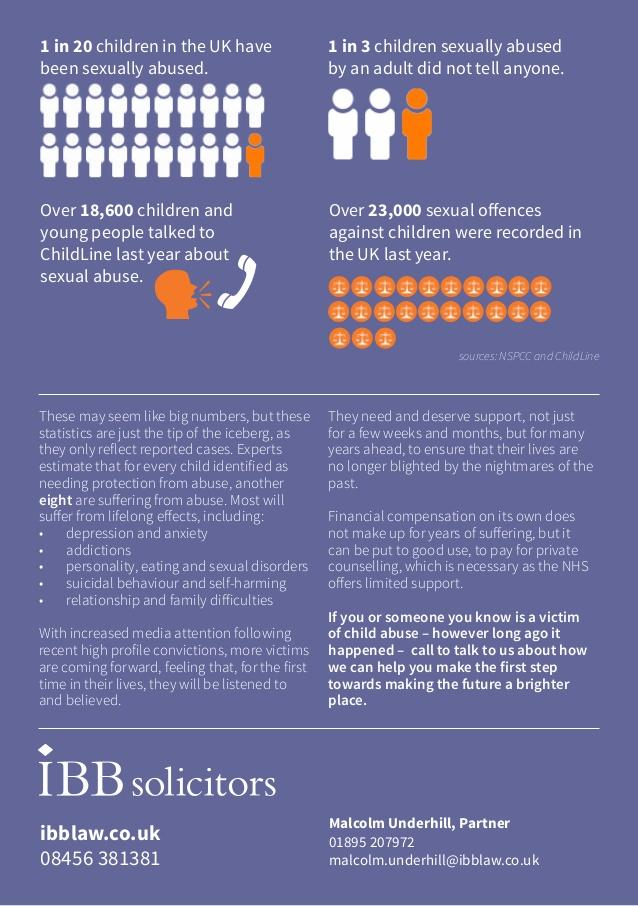Draw attention to some important aspects in this diagram. According to a study, approximately two-thirds of children who were sexually abused by an adult told someone about the abuse. 